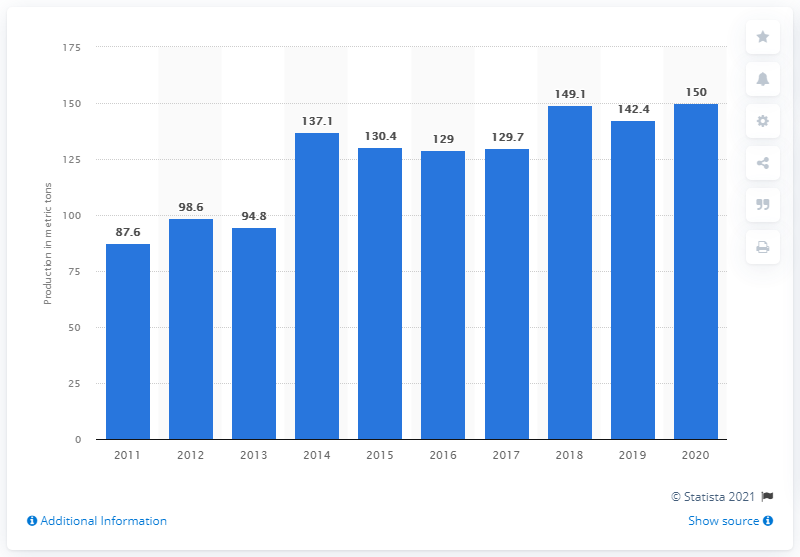Give some essential details in this illustration. In the year 2020, Ghana's gold production reached 150 metric tons. 